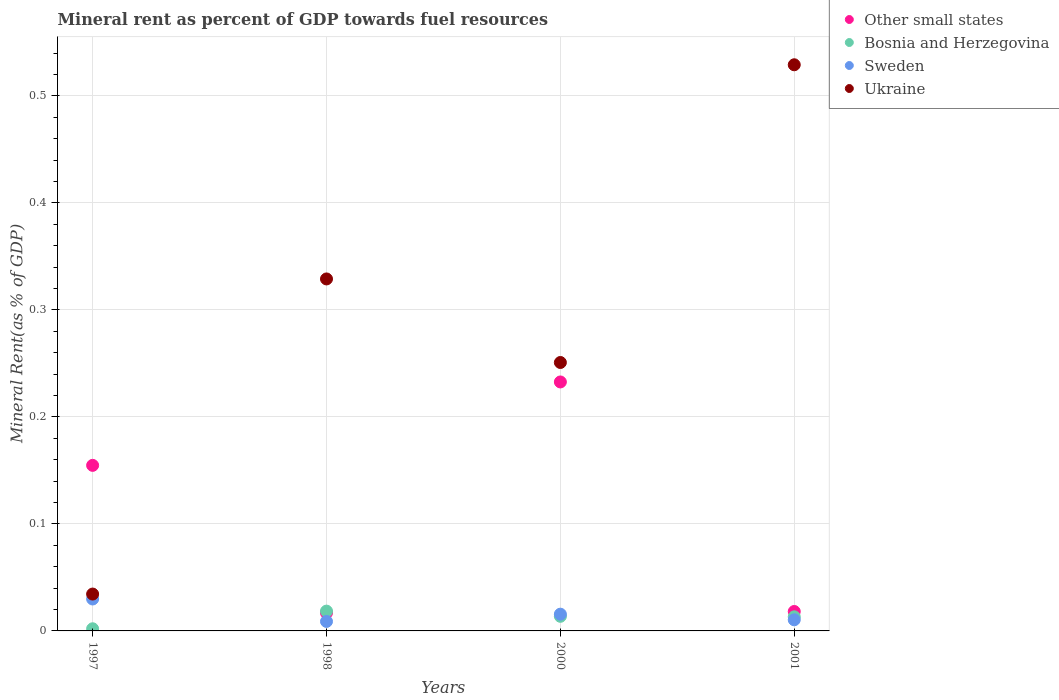How many different coloured dotlines are there?
Provide a short and direct response. 4. Is the number of dotlines equal to the number of legend labels?
Offer a terse response. Yes. What is the mineral rent in Sweden in 1998?
Give a very brief answer. 0.01. Across all years, what is the maximum mineral rent in Bosnia and Herzegovina?
Provide a short and direct response. 0.02. Across all years, what is the minimum mineral rent in Ukraine?
Offer a very short reply. 0.03. In which year was the mineral rent in Bosnia and Herzegovina maximum?
Keep it short and to the point. 1998. What is the total mineral rent in Ukraine in the graph?
Make the answer very short. 1.14. What is the difference between the mineral rent in Sweden in 1998 and that in 2000?
Provide a short and direct response. -0.01. What is the difference between the mineral rent in Other small states in 2001 and the mineral rent in Bosnia and Herzegovina in 2000?
Provide a succinct answer. 0. What is the average mineral rent in Sweden per year?
Your response must be concise. 0.02. In the year 1997, what is the difference between the mineral rent in Other small states and mineral rent in Bosnia and Herzegovina?
Make the answer very short. 0.15. In how many years, is the mineral rent in Ukraine greater than 0.16 %?
Your answer should be compact. 3. What is the ratio of the mineral rent in Other small states in 1997 to that in 2000?
Your response must be concise. 0.66. Is the difference between the mineral rent in Other small states in 1997 and 2001 greater than the difference between the mineral rent in Bosnia and Herzegovina in 1997 and 2001?
Ensure brevity in your answer.  Yes. What is the difference between the highest and the second highest mineral rent in Ukraine?
Give a very brief answer. 0.2. What is the difference between the highest and the lowest mineral rent in Ukraine?
Make the answer very short. 0.49. Is it the case that in every year, the sum of the mineral rent in Bosnia and Herzegovina and mineral rent in Ukraine  is greater than the mineral rent in Sweden?
Ensure brevity in your answer.  Yes. Is the mineral rent in Sweden strictly less than the mineral rent in Other small states over the years?
Your answer should be compact. Yes. What is the difference between two consecutive major ticks on the Y-axis?
Give a very brief answer. 0.1. Does the graph contain grids?
Give a very brief answer. Yes. Where does the legend appear in the graph?
Your answer should be compact. Top right. How many legend labels are there?
Provide a short and direct response. 4. What is the title of the graph?
Your response must be concise. Mineral rent as percent of GDP towards fuel resources. Does "Cambodia" appear as one of the legend labels in the graph?
Give a very brief answer. No. What is the label or title of the Y-axis?
Offer a very short reply. Mineral Rent(as % of GDP). What is the Mineral Rent(as % of GDP) of Other small states in 1997?
Offer a terse response. 0.15. What is the Mineral Rent(as % of GDP) in Bosnia and Herzegovina in 1997?
Offer a terse response. 0. What is the Mineral Rent(as % of GDP) in Sweden in 1997?
Offer a terse response. 0.03. What is the Mineral Rent(as % of GDP) of Ukraine in 1997?
Your response must be concise. 0.03. What is the Mineral Rent(as % of GDP) of Other small states in 1998?
Offer a very short reply. 0.02. What is the Mineral Rent(as % of GDP) of Bosnia and Herzegovina in 1998?
Ensure brevity in your answer.  0.02. What is the Mineral Rent(as % of GDP) of Sweden in 1998?
Ensure brevity in your answer.  0.01. What is the Mineral Rent(as % of GDP) of Ukraine in 1998?
Your response must be concise. 0.33. What is the Mineral Rent(as % of GDP) in Other small states in 2000?
Your response must be concise. 0.23. What is the Mineral Rent(as % of GDP) in Bosnia and Herzegovina in 2000?
Your answer should be compact. 0.01. What is the Mineral Rent(as % of GDP) in Sweden in 2000?
Keep it short and to the point. 0.02. What is the Mineral Rent(as % of GDP) in Ukraine in 2000?
Make the answer very short. 0.25. What is the Mineral Rent(as % of GDP) of Other small states in 2001?
Give a very brief answer. 0.02. What is the Mineral Rent(as % of GDP) in Bosnia and Herzegovina in 2001?
Offer a very short reply. 0.01. What is the Mineral Rent(as % of GDP) of Sweden in 2001?
Provide a short and direct response. 0.01. What is the Mineral Rent(as % of GDP) of Ukraine in 2001?
Provide a short and direct response. 0.53. Across all years, what is the maximum Mineral Rent(as % of GDP) in Other small states?
Your answer should be compact. 0.23. Across all years, what is the maximum Mineral Rent(as % of GDP) of Bosnia and Herzegovina?
Your response must be concise. 0.02. Across all years, what is the maximum Mineral Rent(as % of GDP) in Sweden?
Your answer should be compact. 0.03. Across all years, what is the maximum Mineral Rent(as % of GDP) in Ukraine?
Your response must be concise. 0.53. Across all years, what is the minimum Mineral Rent(as % of GDP) of Other small states?
Your answer should be very brief. 0.02. Across all years, what is the minimum Mineral Rent(as % of GDP) of Bosnia and Herzegovina?
Provide a short and direct response. 0. Across all years, what is the minimum Mineral Rent(as % of GDP) of Sweden?
Keep it short and to the point. 0.01. Across all years, what is the minimum Mineral Rent(as % of GDP) of Ukraine?
Your answer should be compact. 0.03. What is the total Mineral Rent(as % of GDP) of Other small states in the graph?
Offer a terse response. 0.42. What is the total Mineral Rent(as % of GDP) of Bosnia and Herzegovina in the graph?
Give a very brief answer. 0.05. What is the total Mineral Rent(as % of GDP) in Sweden in the graph?
Ensure brevity in your answer.  0.06. What is the total Mineral Rent(as % of GDP) of Ukraine in the graph?
Provide a short and direct response. 1.14. What is the difference between the Mineral Rent(as % of GDP) in Other small states in 1997 and that in 1998?
Offer a very short reply. 0.14. What is the difference between the Mineral Rent(as % of GDP) in Bosnia and Herzegovina in 1997 and that in 1998?
Make the answer very short. -0.02. What is the difference between the Mineral Rent(as % of GDP) of Sweden in 1997 and that in 1998?
Offer a very short reply. 0.02. What is the difference between the Mineral Rent(as % of GDP) in Ukraine in 1997 and that in 1998?
Provide a succinct answer. -0.29. What is the difference between the Mineral Rent(as % of GDP) in Other small states in 1997 and that in 2000?
Provide a short and direct response. -0.08. What is the difference between the Mineral Rent(as % of GDP) of Bosnia and Herzegovina in 1997 and that in 2000?
Keep it short and to the point. -0.01. What is the difference between the Mineral Rent(as % of GDP) in Sweden in 1997 and that in 2000?
Provide a short and direct response. 0.01. What is the difference between the Mineral Rent(as % of GDP) in Ukraine in 1997 and that in 2000?
Your answer should be compact. -0.22. What is the difference between the Mineral Rent(as % of GDP) of Other small states in 1997 and that in 2001?
Give a very brief answer. 0.14. What is the difference between the Mineral Rent(as % of GDP) in Bosnia and Herzegovina in 1997 and that in 2001?
Your response must be concise. -0.01. What is the difference between the Mineral Rent(as % of GDP) of Sweden in 1997 and that in 2001?
Your response must be concise. 0.02. What is the difference between the Mineral Rent(as % of GDP) in Ukraine in 1997 and that in 2001?
Provide a succinct answer. -0.49. What is the difference between the Mineral Rent(as % of GDP) of Other small states in 1998 and that in 2000?
Keep it short and to the point. -0.22. What is the difference between the Mineral Rent(as % of GDP) in Bosnia and Herzegovina in 1998 and that in 2000?
Your answer should be compact. 0. What is the difference between the Mineral Rent(as % of GDP) of Sweden in 1998 and that in 2000?
Provide a short and direct response. -0.01. What is the difference between the Mineral Rent(as % of GDP) in Ukraine in 1998 and that in 2000?
Provide a succinct answer. 0.08. What is the difference between the Mineral Rent(as % of GDP) in Other small states in 1998 and that in 2001?
Ensure brevity in your answer.  -0. What is the difference between the Mineral Rent(as % of GDP) of Bosnia and Herzegovina in 1998 and that in 2001?
Keep it short and to the point. 0.01. What is the difference between the Mineral Rent(as % of GDP) of Sweden in 1998 and that in 2001?
Provide a short and direct response. -0. What is the difference between the Mineral Rent(as % of GDP) in Ukraine in 1998 and that in 2001?
Ensure brevity in your answer.  -0.2. What is the difference between the Mineral Rent(as % of GDP) of Other small states in 2000 and that in 2001?
Offer a terse response. 0.21. What is the difference between the Mineral Rent(as % of GDP) in Bosnia and Herzegovina in 2000 and that in 2001?
Provide a succinct answer. 0. What is the difference between the Mineral Rent(as % of GDP) of Sweden in 2000 and that in 2001?
Your answer should be compact. 0.01. What is the difference between the Mineral Rent(as % of GDP) in Ukraine in 2000 and that in 2001?
Keep it short and to the point. -0.28. What is the difference between the Mineral Rent(as % of GDP) of Other small states in 1997 and the Mineral Rent(as % of GDP) of Bosnia and Herzegovina in 1998?
Provide a short and direct response. 0.14. What is the difference between the Mineral Rent(as % of GDP) in Other small states in 1997 and the Mineral Rent(as % of GDP) in Sweden in 1998?
Keep it short and to the point. 0.15. What is the difference between the Mineral Rent(as % of GDP) of Other small states in 1997 and the Mineral Rent(as % of GDP) of Ukraine in 1998?
Offer a very short reply. -0.17. What is the difference between the Mineral Rent(as % of GDP) in Bosnia and Herzegovina in 1997 and the Mineral Rent(as % of GDP) in Sweden in 1998?
Offer a terse response. -0.01. What is the difference between the Mineral Rent(as % of GDP) in Bosnia and Herzegovina in 1997 and the Mineral Rent(as % of GDP) in Ukraine in 1998?
Give a very brief answer. -0.33. What is the difference between the Mineral Rent(as % of GDP) of Sweden in 1997 and the Mineral Rent(as % of GDP) of Ukraine in 1998?
Make the answer very short. -0.3. What is the difference between the Mineral Rent(as % of GDP) in Other small states in 1997 and the Mineral Rent(as % of GDP) in Bosnia and Herzegovina in 2000?
Your answer should be compact. 0.14. What is the difference between the Mineral Rent(as % of GDP) of Other small states in 1997 and the Mineral Rent(as % of GDP) of Sweden in 2000?
Offer a terse response. 0.14. What is the difference between the Mineral Rent(as % of GDP) in Other small states in 1997 and the Mineral Rent(as % of GDP) in Ukraine in 2000?
Keep it short and to the point. -0.1. What is the difference between the Mineral Rent(as % of GDP) of Bosnia and Herzegovina in 1997 and the Mineral Rent(as % of GDP) of Sweden in 2000?
Provide a succinct answer. -0.01. What is the difference between the Mineral Rent(as % of GDP) in Bosnia and Herzegovina in 1997 and the Mineral Rent(as % of GDP) in Ukraine in 2000?
Your answer should be very brief. -0.25. What is the difference between the Mineral Rent(as % of GDP) of Sweden in 1997 and the Mineral Rent(as % of GDP) of Ukraine in 2000?
Keep it short and to the point. -0.22. What is the difference between the Mineral Rent(as % of GDP) in Other small states in 1997 and the Mineral Rent(as % of GDP) in Bosnia and Herzegovina in 2001?
Ensure brevity in your answer.  0.14. What is the difference between the Mineral Rent(as % of GDP) of Other small states in 1997 and the Mineral Rent(as % of GDP) of Sweden in 2001?
Ensure brevity in your answer.  0.14. What is the difference between the Mineral Rent(as % of GDP) in Other small states in 1997 and the Mineral Rent(as % of GDP) in Ukraine in 2001?
Give a very brief answer. -0.37. What is the difference between the Mineral Rent(as % of GDP) of Bosnia and Herzegovina in 1997 and the Mineral Rent(as % of GDP) of Sweden in 2001?
Offer a terse response. -0.01. What is the difference between the Mineral Rent(as % of GDP) of Bosnia and Herzegovina in 1997 and the Mineral Rent(as % of GDP) of Ukraine in 2001?
Give a very brief answer. -0.53. What is the difference between the Mineral Rent(as % of GDP) in Sweden in 1997 and the Mineral Rent(as % of GDP) in Ukraine in 2001?
Your answer should be compact. -0.5. What is the difference between the Mineral Rent(as % of GDP) of Other small states in 1998 and the Mineral Rent(as % of GDP) of Bosnia and Herzegovina in 2000?
Your answer should be compact. 0. What is the difference between the Mineral Rent(as % of GDP) of Other small states in 1998 and the Mineral Rent(as % of GDP) of Sweden in 2000?
Your answer should be compact. 0. What is the difference between the Mineral Rent(as % of GDP) of Other small states in 1998 and the Mineral Rent(as % of GDP) of Ukraine in 2000?
Ensure brevity in your answer.  -0.23. What is the difference between the Mineral Rent(as % of GDP) of Bosnia and Herzegovina in 1998 and the Mineral Rent(as % of GDP) of Sweden in 2000?
Your answer should be compact. 0. What is the difference between the Mineral Rent(as % of GDP) in Bosnia and Herzegovina in 1998 and the Mineral Rent(as % of GDP) in Ukraine in 2000?
Keep it short and to the point. -0.23. What is the difference between the Mineral Rent(as % of GDP) in Sweden in 1998 and the Mineral Rent(as % of GDP) in Ukraine in 2000?
Provide a succinct answer. -0.24. What is the difference between the Mineral Rent(as % of GDP) in Other small states in 1998 and the Mineral Rent(as % of GDP) in Bosnia and Herzegovina in 2001?
Your answer should be compact. 0. What is the difference between the Mineral Rent(as % of GDP) of Other small states in 1998 and the Mineral Rent(as % of GDP) of Sweden in 2001?
Ensure brevity in your answer.  0.01. What is the difference between the Mineral Rent(as % of GDP) of Other small states in 1998 and the Mineral Rent(as % of GDP) of Ukraine in 2001?
Offer a terse response. -0.51. What is the difference between the Mineral Rent(as % of GDP) in Bosnia and Herzegovina in 1998 and the Mineral Rent(as % of GDP) in Sweden in 2001?
Offer a terse response. 0.01. What is the difference between the Mineral Rent(as % of GDP) of Bosnia and Herzegovina in 1998 and the Mineral Rent(as % of GDP) of Ukraine in 2001?
Your answer should be very brief. -0.51. What is the difference between the Mineral Rent(as % of GDP) of Sweden in 1998 and the Mineral Rent(as % of GDP) of Ukraine in 2001?
Provide a succinct answer. -0.52. What is the difference between the Mineral Rent(as % of GDP) in Other small states in 2000 and the Mineral Rent(as % of GDP) in Bosnia and Herzegovina in 2001?
Offer a terse response. 0.22. What is the difference between the Mineral Rent(as % of GDP) in Other small states in 2000 and the Mineral Rent(as % of GDP) in Sweden in 2001?
Ensure brevity in your answer.  0.22. What is the difference between the Mineral Rent(as % of GDP) in Other small states in 2000 and the Mineral Rent(as % of GDP) in Ukraine in 2001?
Make the answer very short. -0.3. What is the difference between the Mineral Rent(as % of GDP) of Bosnia and Herzegovina in 2000 and the Mineral Rent(as % of GDP) of Sweden in 2001?
Give a very brief answer. 0. What is the difference between the Mineral Rent(as % of GDP) of Bosnia and Herzegovina in 2000 and the Mineral Rent(as % of GDP) of Ukraine in 2001?
Make the answer very short. -0.52. What is the difference between the Mineral Rent(as % of GDP) of Sweden in 2000 and the Mineral Rent(as % of GDP) of Ukraine in 2001?
Your answer should be very brief. -0.51. What is the average Mineral Rent(as % of GDP) in Other small states per year?
Keep it short and to the point. 0.11. What is the average Mineral Rent(as % of GDP) in Bosnia and Herzegovina per year?
Your response must be concise. 0.01. What is the average Mineral Rent(as % of GDP) in Sweden per year?
Provide a succinct answer. 0.02. What is the average Mineral Rent(as % of GDP) of Ukraine per year?
Your answer should be compact. 0.29. In the year 1997, what is the difference between the Mineral Rent(as % of GDP) of Other small states and Mineral Rent(as % of GDP) of Bosnia and Herzegovina?
Your response must be concise. 0.15. In the year 1997, what is the difference between the Mineral Rent(as % of GDP) in Other small states and Mineral Rent(as % of GDP) in Sweden?
Provide a succinct answer. 0.12. In the year 1997, what is the difference between the Mineral Rent(as % of GDP) in Other small states and Mineral Rent(as % of GDP) in Ukraine?
Make the answer very short. 0.12. In the year 1997, what is the difference between the Mineral Rent(as % of GDP) in Bosnia and Herzegovina and Mineral Rent(as % of GDP) in Sweden?
Give a very brief answer. -0.03. In the year 1997, what is the difference between the Mineral Rent(as % of GDP) in Bosnia and Herzegovina and Mineral Rent(as % of GDP) in Ukraine?
Offer a very short reply. -0.03. In the year 1997, what is the difference between the Mineral Rent(as % of GDP) in Sweden and Mineral Rent(as % of GDP) in Ukraine?
Ensure brevity in your answer.  -0. In the year 1998, what is the difference between the Mineral Rent(as % of GDP) of Other small states and Mineral Rent(as % of GDP) of Bosnia and Herzegovina?
Your answer should be very brief. -0. In the year 1998, what is the difference between the Mineral Rent(as % of GDP) of Other small states and Mineral Rent(as % of GDP) of Sweden?
Keep it short and to the point. 0.01. In the year 1998, what is the difference between the Mineral Rent(as % of GDP) in Other small states and Mineral Rent(as % of GDP) in Ukraine?
Offer a terse response. -0.31. In the year 1998, what is the difference between the Mineral Rent(as % of GDP) of Bosnia and Herzegovina and Mineral Rent(as % of GDP) of Sweden?
Offer a very short reply. 0.01. In the year 1998, what is the difference between the Mineral Rent(as % of GDP) in Bosnia and Herzegovina and Mineral Rent(as % of GDP) in Ukraine?
Ensure brevity in your answer.  -0.31. In the year 1998, what is the difference between the Mineral Rent(as % of GDP) of Sweden and Mineral Rent(as % of GDP) of Ukraine?
Make the answer very short. -0.32. In the year 2000, what is the difference between the Mineral Rent(as % of GDP) of Other small states and Mineral Rent(as % of GDP) of Bosnia and Herzegovina?
Your response must be concise. 0.22. In the year 2000, what is the difference between the Mineral Rent(as % of GDP) of Other small states and Mineral Rent(as % of GDP) of Sweden?
Provide a succinct answer. 0.22. In the year 2000, what is the difference between the Mineral Rent(as % of GDP) in Other small states and Mineral Rent(as % of GDP) in Ukraine?
Give a very brief answer. -0.02. In the year 2000, what is the difference between the Mineral Rent(as % of GDP) in Bosnia and Herzegovina and Mineral Rent(as % of GDP) in Sweden?
Ensure brevity in your answer.  -0. In the year 2000, what is the difference between the Mineral Rent(as % of GDP) of Bosnia and Herzegovina and Mineral Rent(as % of GDP) of Ukraine?
Your answer should be compact. -0.24. In the year 2000, what is the difference between the Mineral Rent(as % of GDP) of Sweden and Mineral Rent(as % of GDP) of Ukraine?
Keep it short and to the point. -0.24. In the year 2001, what is the difference between the Mineral Rent(as % of GDP) of Other small states and Mineral Rent(as % of GDP) of Bosnia and Herzegovina?
Your answer should be compact. 0.01. In the year 2001, what is the difference between the Mineral Rent(as % of GDP) of Other small states and Mineral Rent(as % of GDP) of Sweden?
Keep it short and to the point. 0.01. In the year 2001, what is the difference between the Mineral Rent(as % of GDP) in Other small states and Mineral Rent(as % of GDP) in Ukraine?
Offer a very short reply. -0.51. In the year 2001, what is the difference between the Mineral Rent(as % of GDP) in Bosnia and Herzegovina and Mineral Rent(as % of GDP) in Sweden?
Keep it short and to the point. 0. In the year 2001, what is the difference between the Mineral Rent(as % of GDP) in Bosnia and Herzegovina and Mineral Rent(as % of GDP) in Ukraine?
Keep it short and to the point. -0.52. In the year 2001, what is the difference between the Mineral Rent(as % of GDP) of Sweden and Mineral Rent(as % of GDP) of Ukraine?
Ensure brevity in your answer.  -0.52. What is the ratio of the Mineral Rent(as % of GDP) in Other small states in 1997 to that in 1998?
Provide a short and direct response. 9.15. What is the ratio of the Mineral Rent(as % of GDP) of Bosnia and Herzegovina in 1997 to that in 1998?
Your answer should be compact. 0.11. What is the ratio of the Mineral Rent(as % of GDP) in Sweden in 1997 to that in 1998?
Offer a very short reply. 3.36. What is the ratio of the Mineral Rent(as % of GDP) of Ukraine in 1997 to that in 1998?
Your answer should be compact. 0.1. What is the ratio of the Mineral Rent(as % of GDP) of Other small states in 1997 to that in 2000?
Give a very brief answer. 0.67. What is the ratio of the Mineral Rent(as % of GDP) in Bosnia and Herzegovina in 1997 to that in 2000?
Give a very brief answer. 0.15. What is the ratio of the Mineral Rent(as % of GDP) in Sweden in 1997 to that in 2000?
Keep it short and to the point. 1.91. What is the ratio of the Mineral Rent(as % of GDP) of Ukraine in 1997 to that in 2000?
Offer a terse response. 0.14. What is the ratio of the Mineral Rent(as % of GDP) of Other small states in 1997 to that in 2001?
Keep it short and to the point. 8.52. What is the ratio of the Mineral Rent(as % of GDP) in Bosnia and Herzegovina in 1997 to that in 2001?
Ensure brevity in your answer.  0.15. What is the ratio of the Mineral Rent(as % of GDP) of Sweden in 1997 to that in 2001?
Your response must be concise. 2.87. What is the ratio of the Mineral Rent(as % of GDP) in Ukraine in 1997 to that in 2001?
Your answer should be compact. 0.07. What is the ratio of the Mineral Rent(as % of GDP) of Other small states in 1998 to that in 2000?
Offer a terse response. 0.07. What is the ratio of the Mineral Rent(as % of GDP) of Bosnia and Herzegovina in 1998 to that in 2000?
Ensure brevity in your answer.  1.36. What is the ratio of the Mineral Rent(as % of GDP) in Sweden in 1998 to that in 2000?
Your answer should be very brief. 0.57. What is the ratio of the Mineral Rent(as % of GDP) of Ukraine in 1998 to that in 2000?
Keep it short and to the point. 1.31. What is the ratio of the Mineral Rent(as % of GDP) in Other small states in 1998 to that in 2001?
Ensure brevity in your answer.  0.93. What is the ratio of the Mineral Rent(as % of GDP) of Bosnia and Herzegovina in 1998 to that in 2001?
Offer a terse response. 1.4. What is the ratio of the Mineral Rent(as % of GDP) in Sweden in 1998 to that in 2001?
Your response must be concise. 0.85. What is the ratio of the Mineral Rent(as % of GDP) of Ukraine in 1998 to that in 2001?
Your answer should be very brief. 0.62. What is the ratio of the Mineral Rent(as % of GDP) of Other small states in 2000 to that in 2001?
Make the answer very short. 12.81. What is the ratio of the Mineral Rent(as % of GDP) in Bosnia and Herzegovina in 2000 to that in 2001?
Your answer should be very brief. 1.04. What is the ratio of the Mineral Rent(as % of GDP) in Sweden in 2000 to that in 2001?
Keep it short and to the point. 1.5. What is the ratio of the Mineral Rent(as % of GDP) of Ukraine in 2000 to that in 2001?
Your answer should be compact. 0.47. What is the difference between the highest and the second highest Mineral Rent(as % of GDP) of Other small states?
Offer a very short reply. 0.08. What is the difference between the highest and the second highest Mineral Rent(as % of GDP) in Bosnia and Herzegovina?
Keep it short and to the point. 0. What is the difference between the highest and the second highest Mineral Rent(as % of GDP) of Sweden?
Provide a short and direct response. 0.01. What is the difference between the highest and the second highest Mineral Rent(as % of GDP) of Ukraine?
Your response must be concise. 0.2. What is the difference between the highest and the lowest Mineral Rent(as % of GDP) of Other small states?
Provide a short and direct response. 0.22. What is the difference between the highest and the lowest Mineral Rent(as % of GDP) of Bosnia and Herzegovina?
Your answer should be compact. 0.02. What is the difference between the highest and the lowest Mineral Rent(as % of GDP) in Sweden?
Your answer should be very brief. 0.02. What is the difference between the highest and the lowest Mineral Rent(as % of GDP) of Ukraine?
Offer a very short reply. 0.49. 